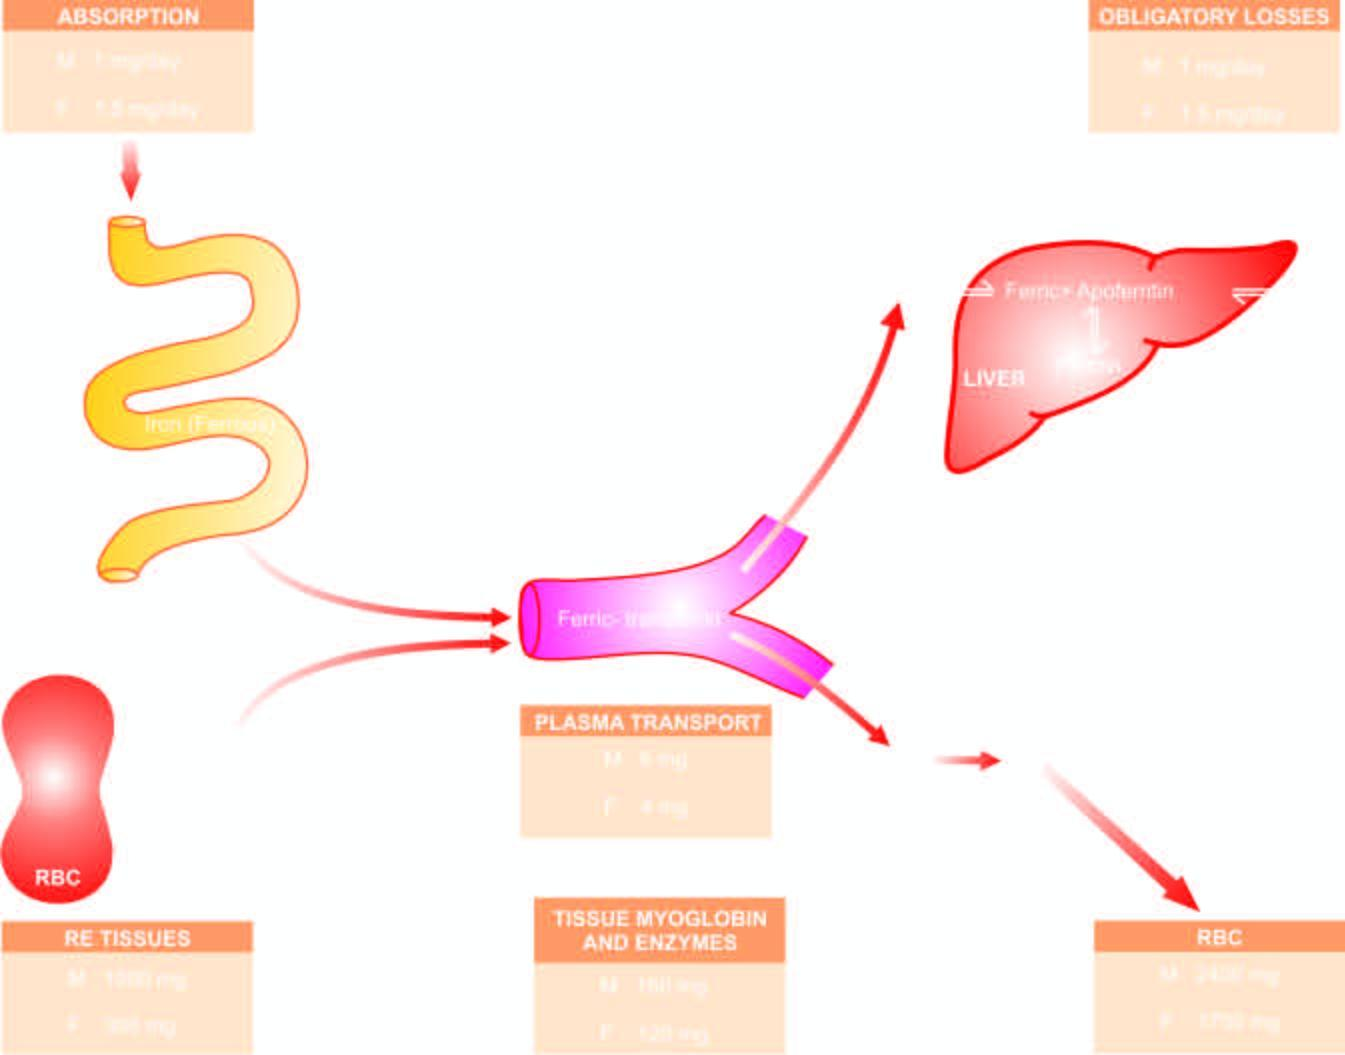whose lifespan are the mature red cells released into?
Answer the question using a single word or phrase. Circulation 